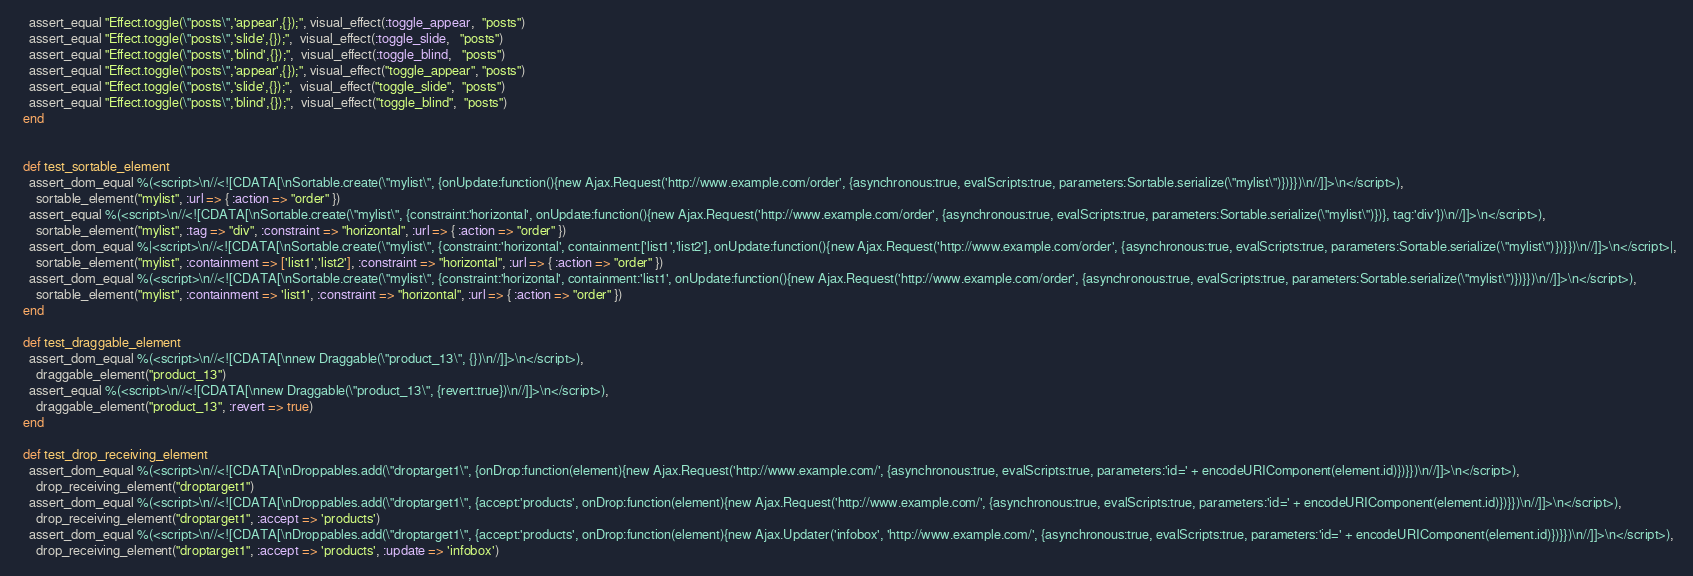Convert code to text. <code><loc_0><loc_0><loc_500><loc_500><_Ruby_>    assert_equal "Effect.toggle(\"posts\",'appear',{});", visual_effect(:toggle_appear,  "posts")
    assert_equal "Effect.toggle(\"posts\",'slide',{});",  visual_effect(:toggle_slide,   "posts")
    assert_equal "Effect.toggle(\"posts\",'blind',{});",  visual_effect(:toggle_blind,   "posts")
    assert_equal "Effect.toggle(\"posts\",'appear',{});", visual_effect("toggle_appear", "posts")
    assert_equal "Effect.toggle(\"posts\",'slide',{});",  visual_effect("toggle_slide",  "posts")
    assert_equal "Effect.toggle(\"posts\",'blind',{});",  visual_effect("toggle_blind",  "posts")
  end


  def test_sortable_element
    assert_dom_equal %(<script>\n//<![CDATA[\nSortable.create(\"mylist\", {onUpdate:function(){new Ajax.Request('http://www.example.com/order', {asynchronous:true, evalScripts:true, parameters:Sortable.serialize(\"mylist\")})}})\n//]]>\n</script>),
      sortable_element("mylist", :url => { :action => "order" })
    assert_equal %(<script>\n//<![CDATA[\nSortable.create(\"mylist\", {constraint:'horizontal', onUpdate:function(){new Ajax.Request('http://www.example.com/order', {asynchronous:true, evalScripts:true, parameters:Sortable.serialize(\"mylist\")})}, tag:'div'})\n//]]>\n</script>),
      sortable_element("mylist", :tag => "div", :constraint => "horizontal", :url => { :action => "order" })
    assert_dom_equal %|<script>\n//<![CDATA[\nSortable.create(\"mylist\", {constraint:'horizontal', containment:['list1','list2'], onUpdate:function(){new Ajax.Request('http://www.example.com/order', {asynchronous:true, evalScripts:true, parameters:Sortable.serialize(\"mylist\")})}})\n//]]>\n</script>|,
      sortable_element("mylist", :containment => ['list1','list2'], :constraint => "horizontal", :url => { :action => "order" })
    assert_dom_equal %(<script>\n//<![CDATA[\nSortable.create(\"mylist\", {constraint:'horizontal', containment:'list1', onUpdate:function(){new Ajax.Request('http://www.example.com/order', {asynchronous:true, evalScripts:true, parameters:Sortable.serialize(\"mylist\")})}})\n//]]>\n</script>),
      sortable_element("mylist", :containment => 'list1', :constraint => "horizontal", :url => { :action => "order" })
  end

  def test_draggable_element
    assert_dom_equal %(<script>\n//<![CDATA[\nnew Draggable(\"product_13\", {})\n//]]>\n</script>),
      draggable_element("product_13")
    assert_equal %(<script>\n//<![CDATA[\nnew Draggable(\"product_13\", {revert:true})\n//]]>\n</script>),
      draggable_element("product_13", :revert => true)
  end

  def test_drop_receiving_element
    assert_dom_equal %(<script>\n//<![CDATA[\nDroppables.add(\"droptarget1\", {onDrop:function(element){new Ajax.Request('http://www.example.com/', {asynchronous:true, evalScripts:true, parameters:'id=' + encodeURIComponent(element.id)})}})\n//]]>\n</script>),
      drop_receiving_element("droptarget1")
    assert_dom_equal %(<script>\n//<![CDATA[\nDroppables.add(\"droptarget1\", {accept:'products', onDrop:function(element){new Ajax.Request('http://www.example.com/', {asynchronous:true, evalScripts:true, parameters:'id=' + encodeURIComponent(element.id)})}})\n//]]>\n</script>),
      drop_receiving_element("droptarget1", :accept => 'products')
    assert_dom_equal %(<script>\n//<![CDATA[\nDroppables.add(\"droptarget1\", {accept:'products', onDrop:function(element){new Ajax.Updater('infobox', 'http://www.example.com/', {asynchronous:true, evalScripts:true, parameters:'id=' + encodeURIComponent(element.id)})}})\n//]]>\n</script>),
      drop_receiving_element("droptarget1", :accept => 'products', :update => 'infobox')</code> 